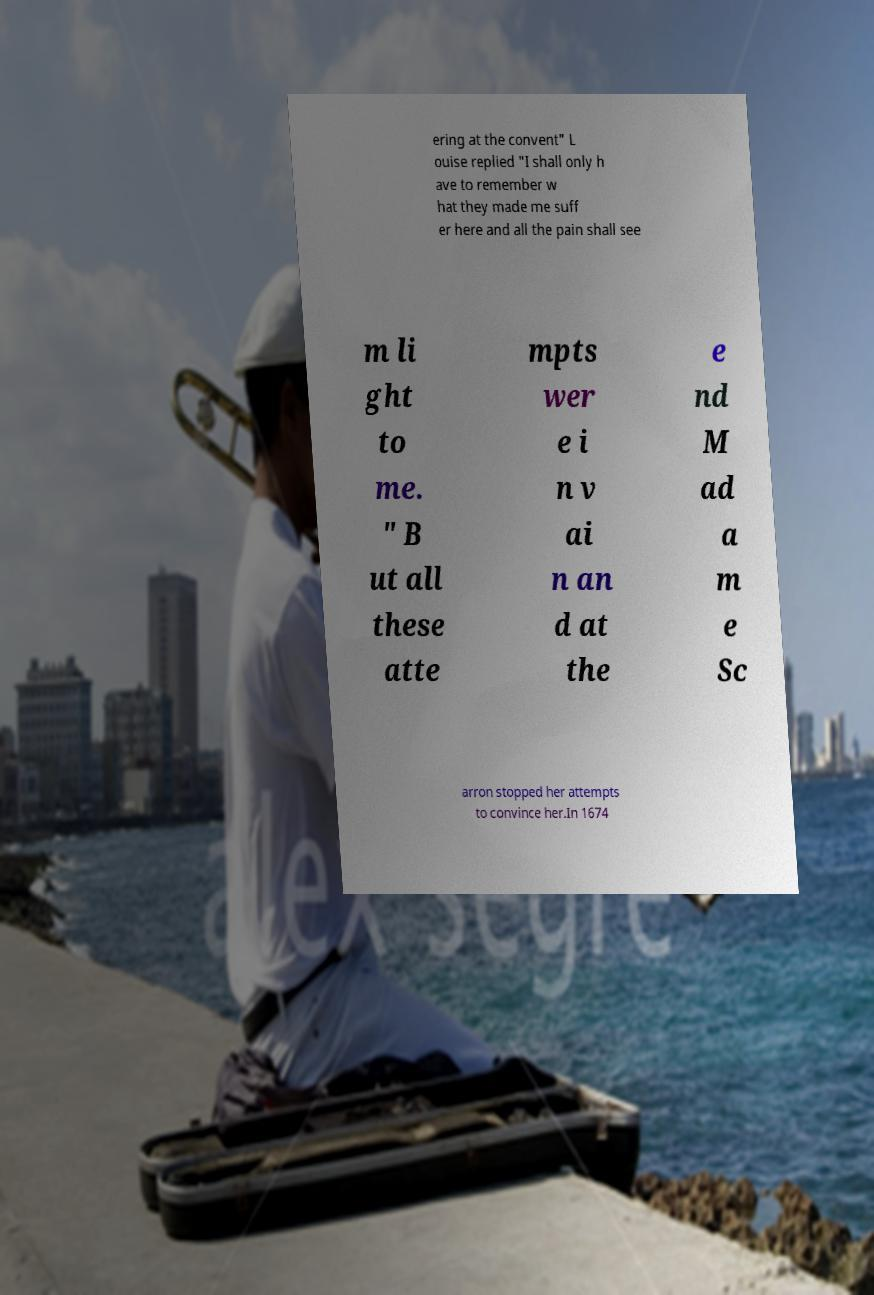Can you accurately transcribe the text from the provided image for me? ering at the convent" L ouise replied "I shall only h ave to remember w hat they made me suff er here and all the pain shall see m li ght to me. " B ut all these atte mpts wer e i n v ai n an d at the e nd M ad a m e Sc arron stopped her attempts to convince her.In 1674 